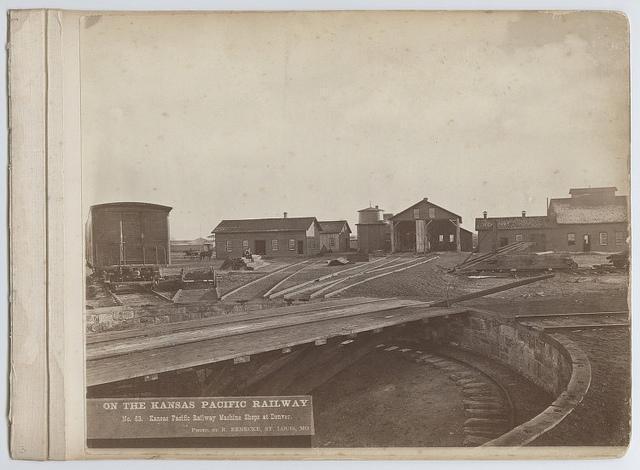How many people are sitting down in the image?
Give a very brief answer. 0. 